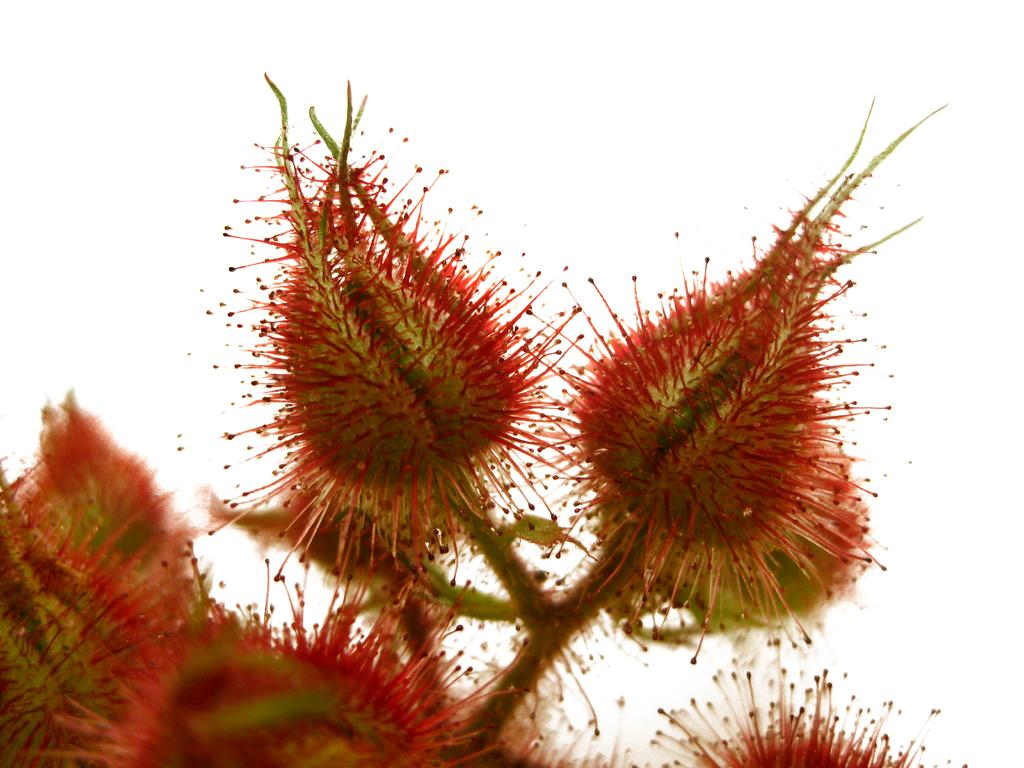What type of living organisms can be seen in the image? Flowers can be seen in the image. Can you describe the flowers in the image? Unfortunately, the facts provided do not give specific details about the flowers. What might be the purpose of the flowers in the image? The purpose of the flowers in the image is not clear from the provided facts. How many legs can be seen on the flowers in the image? Flowers do not have legs, so this question cannot be answered based on the image. 